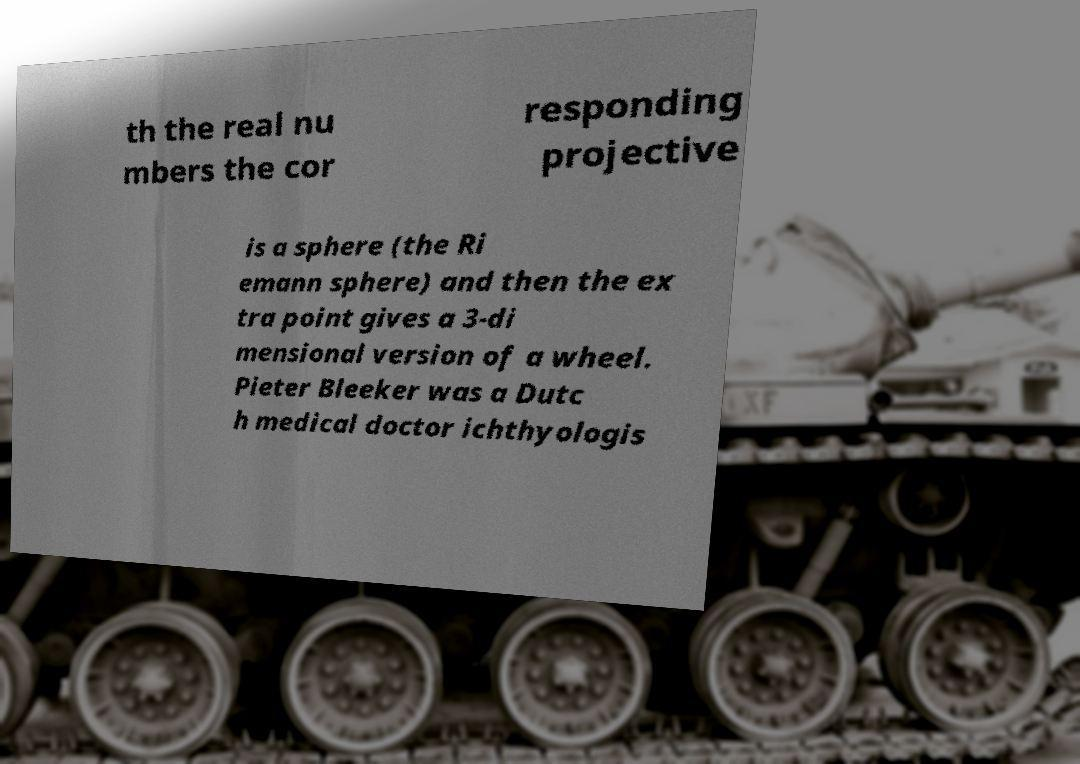What messages or text are displayed in this image? I need them in a readable, typed format. th the real nu mbers the cor responding projective is a sphere (the Ri emann sphere) and then the ex tra point gives a 3-di mensional version of a wheel. Pieter Bleeker was a Dutc h medical doctor ichthyologis 